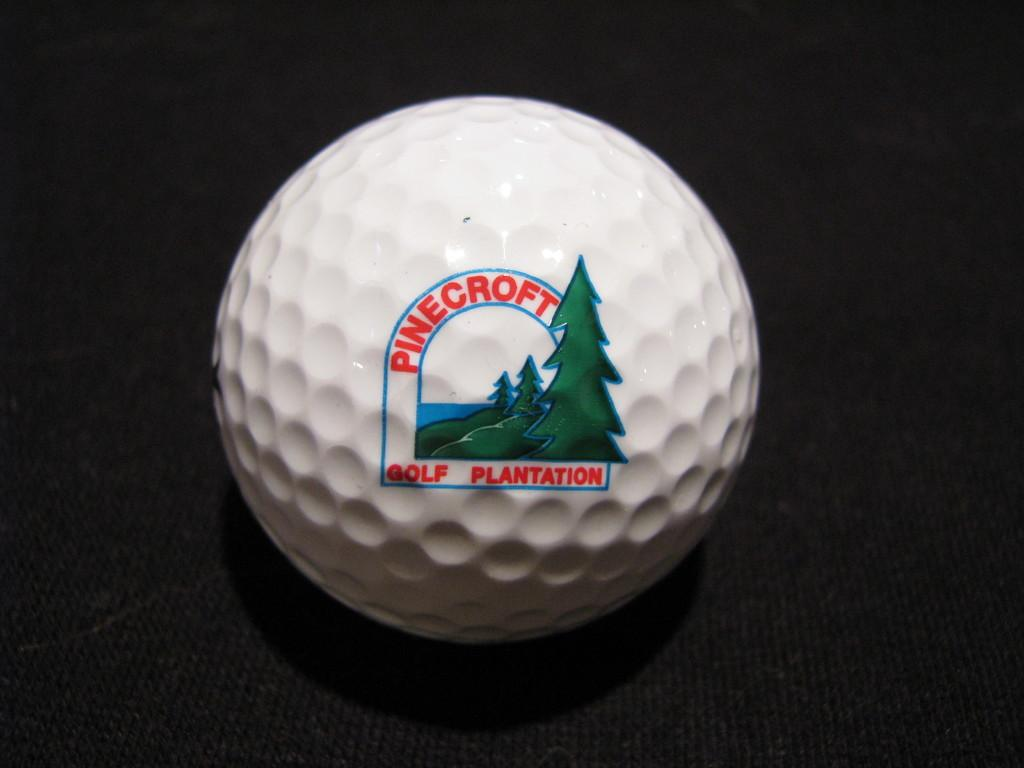<image>
Create a compact narrative representing the image presented. A golf ball from the Pinecroft Golf Plantation course. 